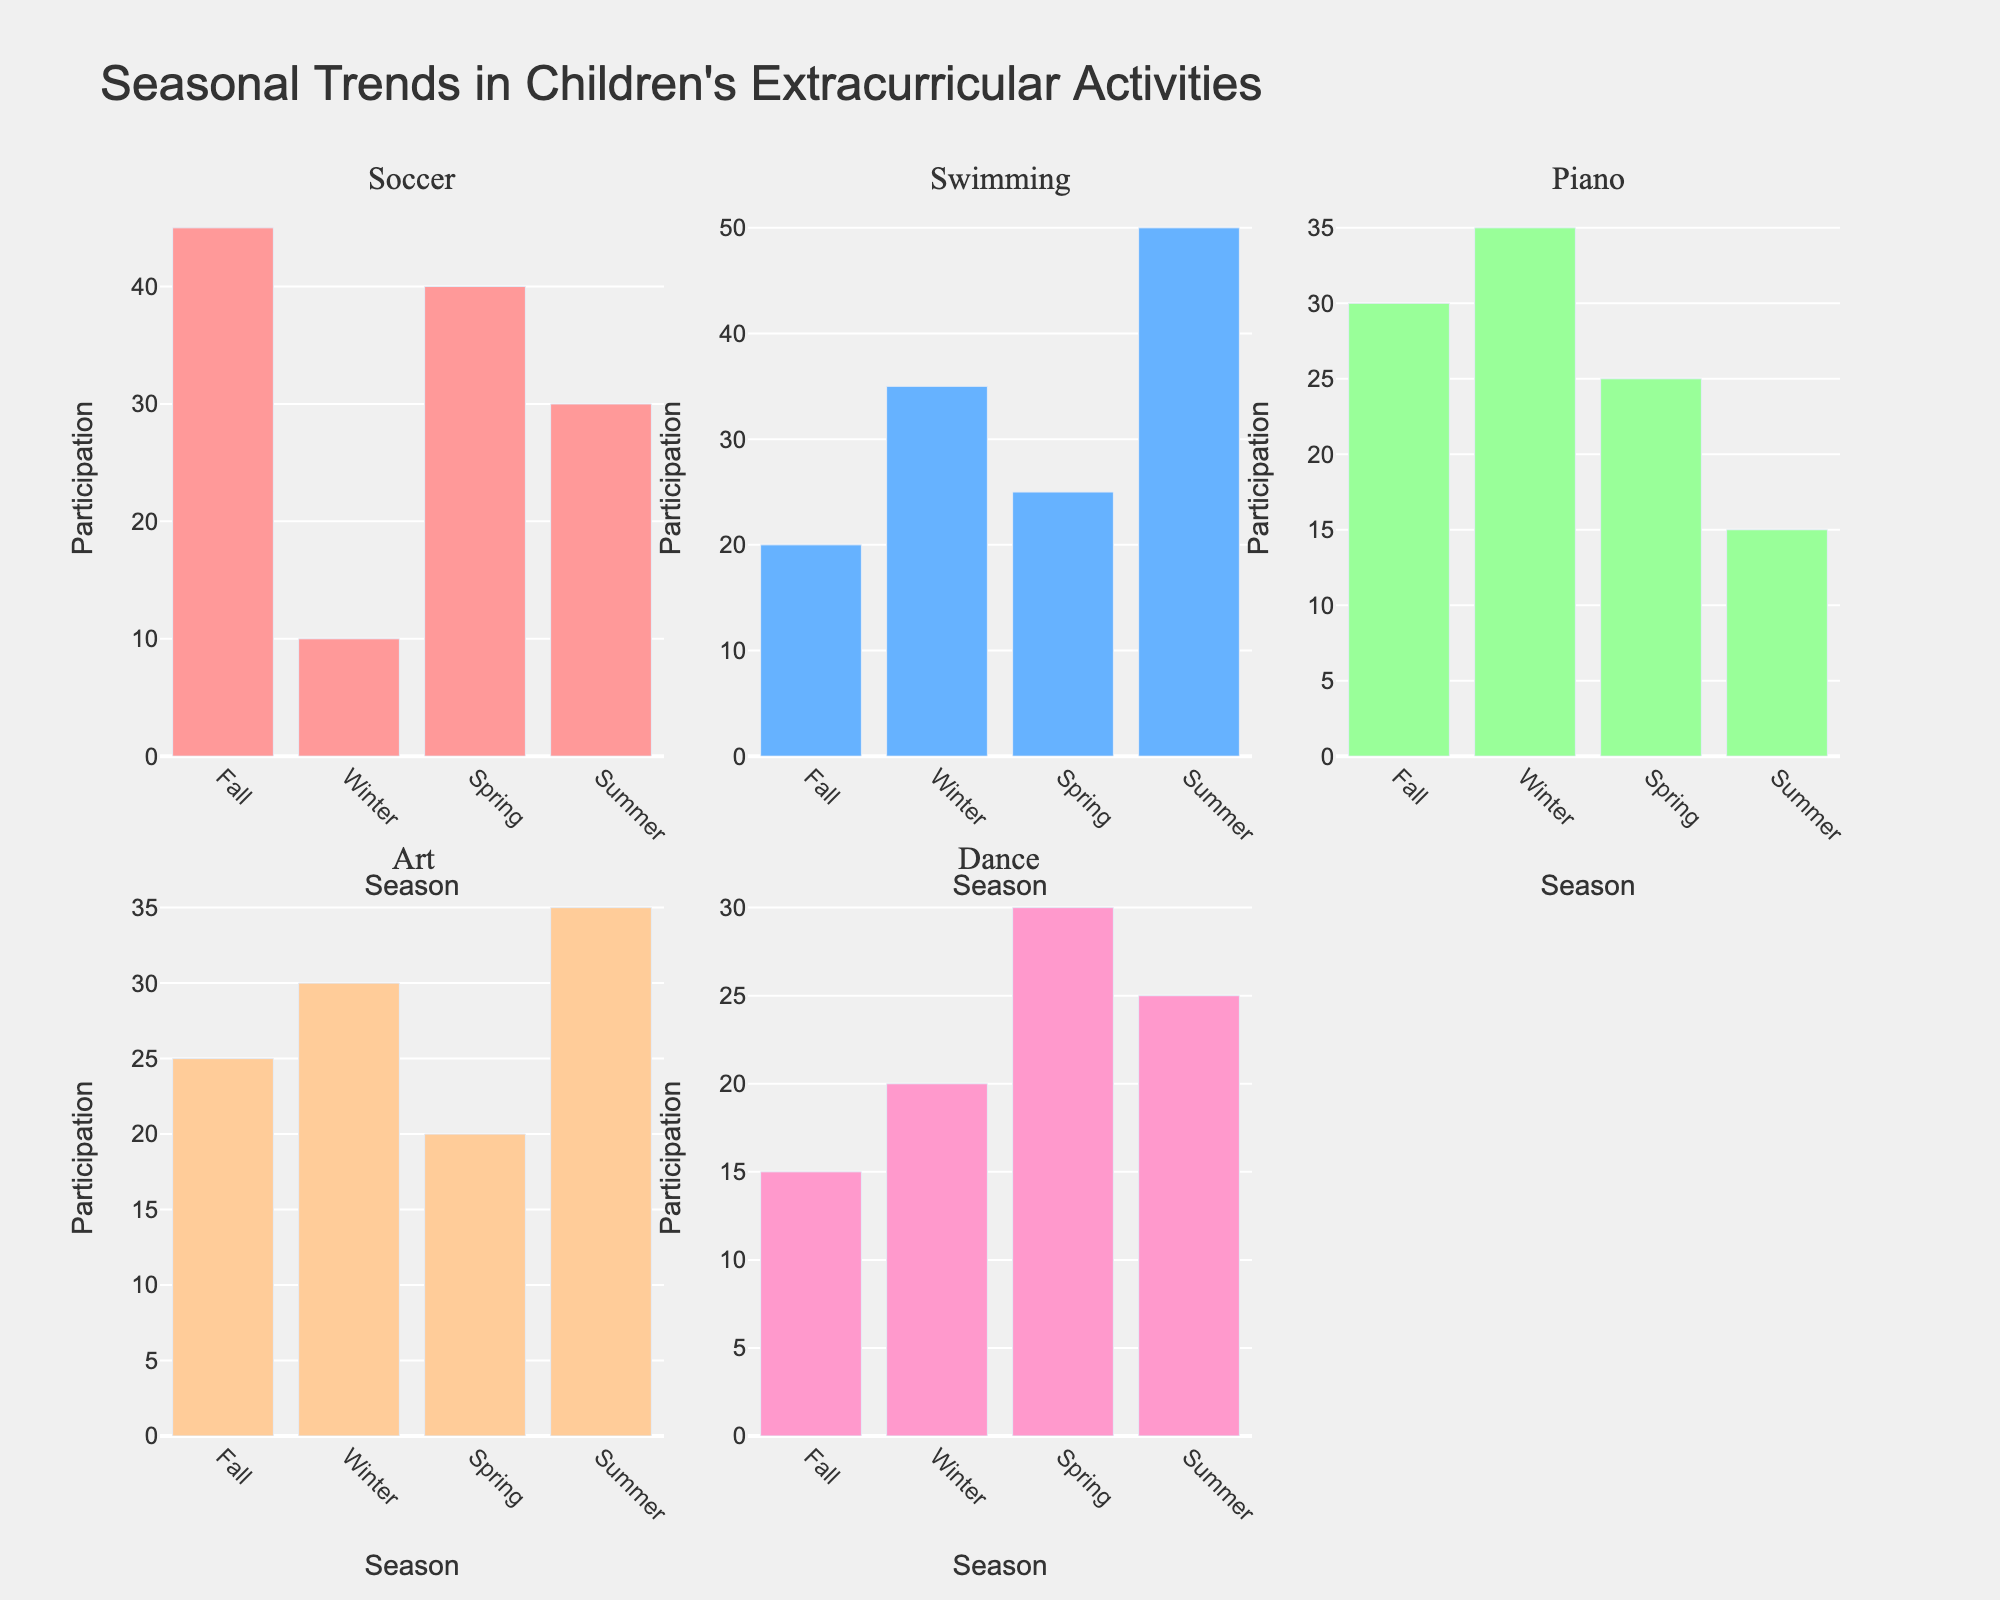What is the title of the figure? The title of the figure is displayed at the top, clearly stating the main subject of the figure. The title is "European Football Leagues Performance (2013-2022)".
Answer: European Football Leagues Performance (2013-2022) Which league had the highest average attendance in the 2021/22 season? In the "Average Attendance" subplot, look for the 2021/22 season and the league with the highest value. Bundesliga has the highest average attendance, around 42,966 attendees.
Answer: Bundesliga How did the average goals per match for La Liga change from the 2013/14 season to the 2021/22 season? In the "Average Goals Per Match" subplot, compare the values for La Liga in the 2013/14 and 2021/22 seasons. It decreased from 2.75 to 2.51 goals per match.
Answer: Decreased Which two leagues had similar UEFA coefficients in the 2013/14 season? In the "UEFA Coefficient" subplot, compare the coefficients of the leagues for the 2013/14 season. The Premier League and La Liga both had a coefficient of 84.605.
Answer: Premier League and La Liga What is the trend in average attendance for the Premier League from 2013/14 to 2021/22? In the "Average Attendance" subplot, trace the points for the Premier League across the given seasons. The attendance increases from 36,631 to 39,989 over the years.
Answer: Increasing Which league saw the highest increase in average goals per match from 2013/14 to 2021/22? Compare the differences in average goals per match for all leagues between 2013/14 and 2021/22. Serie A increased from 2.72 to 2.87, the largest increase among the leagues.
Answer: Serie A How many subplots are there in the figure and what metrics do they show? The figure consists of three subplots, each showing a different metric: Average Goals Per Match, Average Attendance, and UEFA Coefficient.
Answer: Three subplots: Average Goals Per Match, Average Attendance, UEFA Coefficient Did the UEFA coefficient for Serie A improve between 2017/18 and 2021/22? In the "UEFA Coefficient" subplot, compare Serie A's values for the 2017/18 and 2021/22 seasons. It decreased from 70.569 to 67.902.
Answer: No What is the range used for the y-axis in the "Average Attendance" subplot? Check the y-axis of the subplot titled "Average Attendance". The range is specified from 15,000 to 50,000 spectators.
Answer: 15,000 to 50,000 spectators Which league had the lowest UEFA coefficient in the 2021/22 season? In the "UEFA Coefficient" subplot, find the league with the lowest value for the 2021/22 season. Ligue 1 had the lowest coefficient, around 56.081.
Answer: Ligue 1 